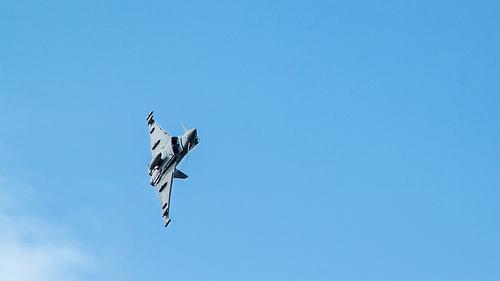How many planes are there?
Give a very brief answer. 1. 